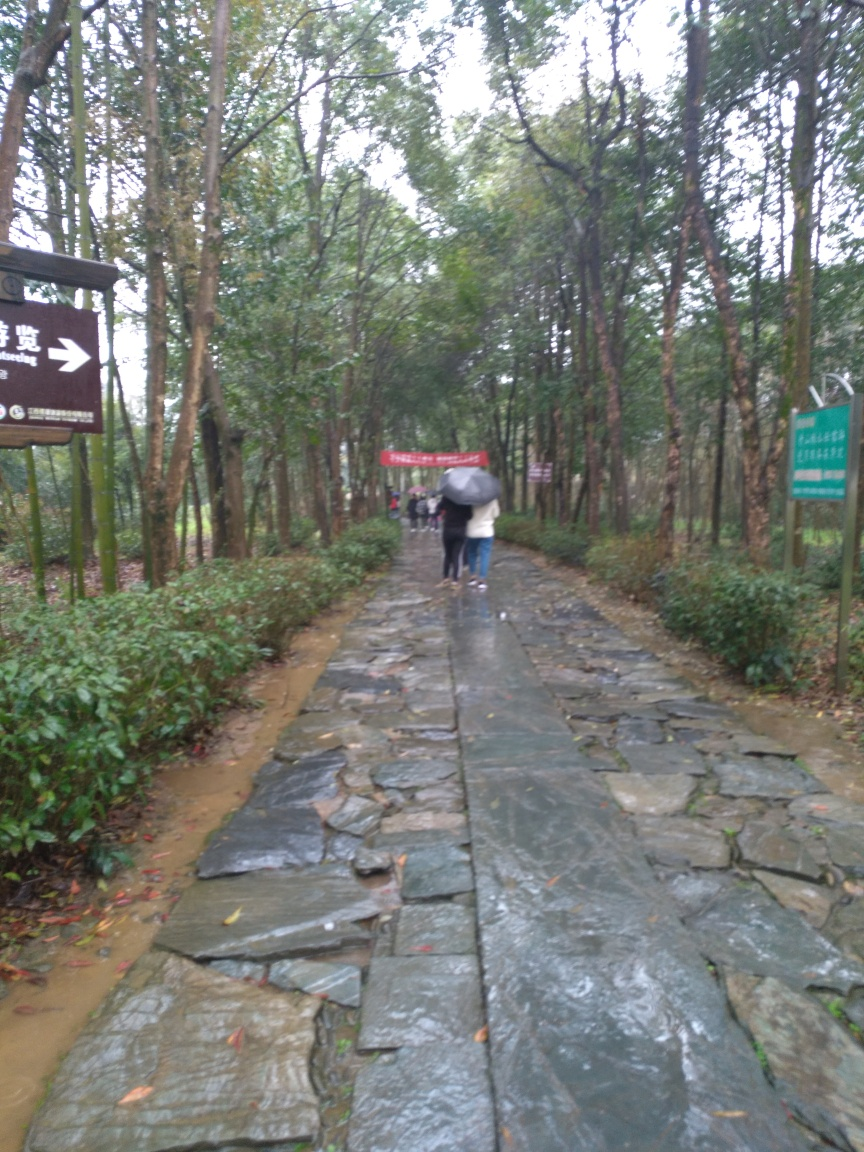What is the overall image quality?
A. High
B. Average
C. Poor
D. Excellent The overall image quality appears to be average, as indicated by certain characteristics such as the lack of sharpness, some blur possibly due to camera movement or focus issues, and somewhat muted colors. These factors contribute to the image not being of high or excellent quality, but it is also not poor as the subject and surroundings are identifiable. 